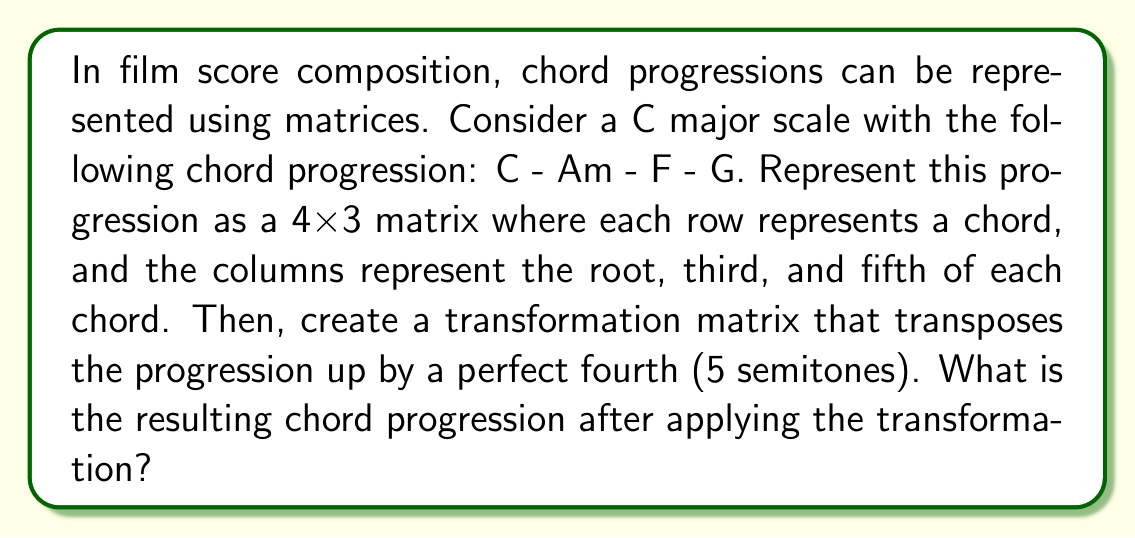Teach me how to tackle this problem. Let's approach this step-by-step:

1) First, we need to represent the initial chord progression as a matrix. In C major:
   C = (C, E, G)
   Am = (A, C, E)
   F = (F, A, C)
   G = (G, B, D)

   We can represent these as numbers, where C=0, C#=1, D=2, etc. So our initial matrix is:

   $$A = \begin{bmatrix}
   0 & 4 & 7 \\
   9 & 0 & 4 \\
   5 & 9 & 0 \\
   7 & 11 & 2
   \end{bmatrix}$$

2) To transpose up by a perfect fourth (5 semitones), we need to add 5 to each element and then take the modulus 12 (since there are 12 semitones in an octave). We can represent this as a transformation matrix:

   $$T = \begin{bmatrix}
   1 & 0 & 0 \\
   0 & 1 & 0 \\
   0 & 0 & 1
   \end{bmatrix}$$

   And an addition vector:

   $$v = \begin{bmatrix}
   5 \\
   5 \\
   5
   \end{bmatrix}$$

3) The transformation can be represented as:

   $$B = (A \times T + v) \bmod 12$$

4) Applying this transformation:

   $$B = \begin{bmatrix}
   5 & 9 & 0 \\
   2 & 5 & 9 \\
   10 & 2 & 5 \\
   0 & 4 & 7
   \end{bmatrix}$$

5) Now we need to interpret this matrix back into chords:
   5 = F, 9 = A, 0 = C : F major
   2 = D, 5 = F, 9 = A : Dm
   10 = A#, 2 = D, 5 = F : B♭
   0 = C, 4 = E, 7 = G : C

Therefore, the new chord progression is F - Dm - B♭ - C.
Answer: F - Dm - B♭ - C 